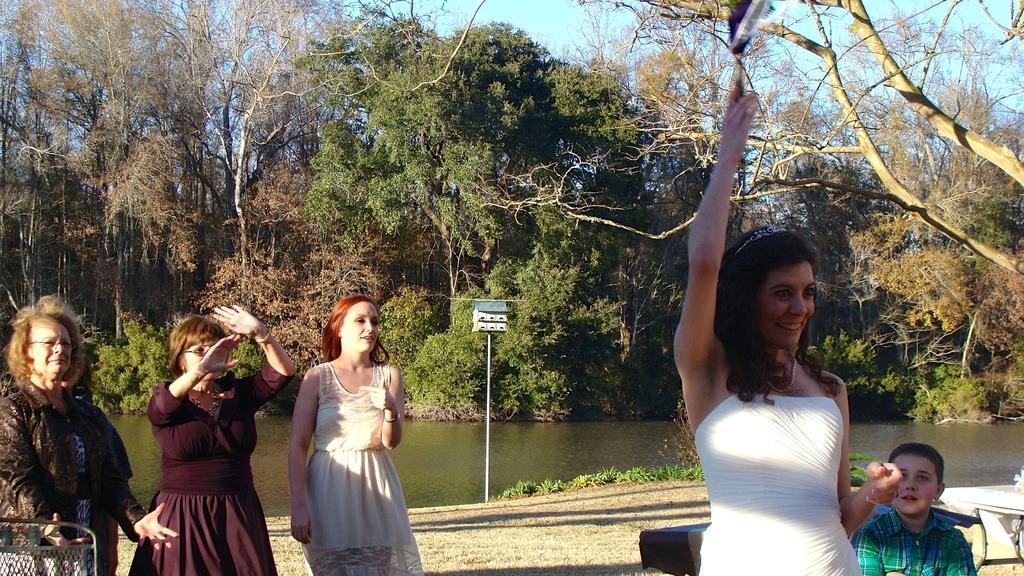Please provide a concise description of this image. In this image, we can see persons wearing clothes. There is a kid in the bottom right of the image. There are some trees beside the lake. There is a pole in the middle of the image. There is a sky at the top of the image. 